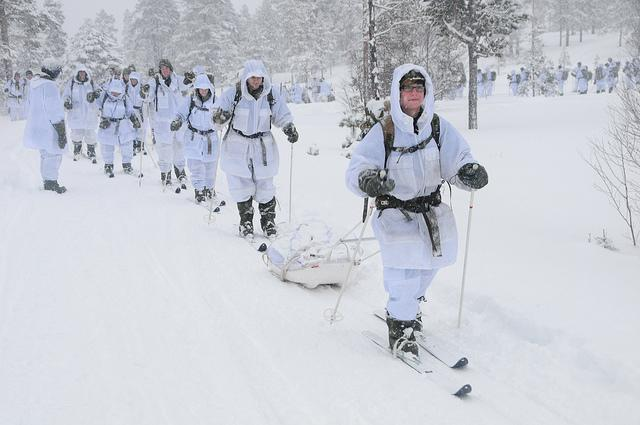What relation does the clothes here have?

Choices:
A) opposites
B) uniforms
C) all unrelated
D) summer clothes uniforms 